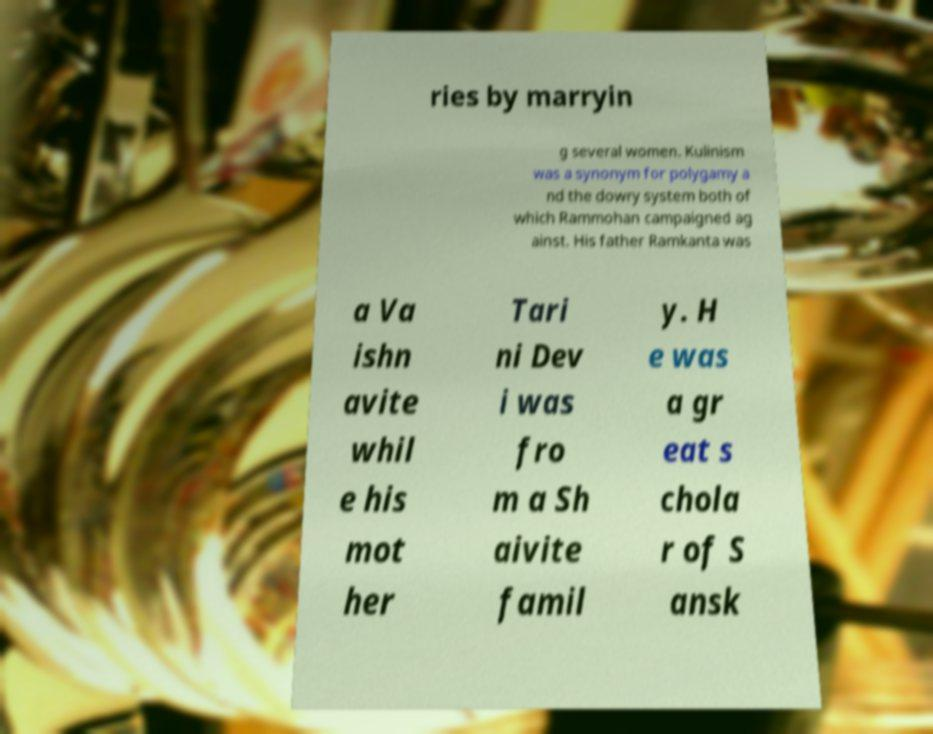For documentation purposes, I need the text within this image transcribed. Could you provide that? ries by marryin g several women. Kulinism was a synonym for polygamy a nd the dowry system both of which Rammohan campaigned ag ainst. His father Ramkanta was a Va ishn avite whil e his mot her Tari ni Dev i was fro m a Sh aivite famil y. H e was a gr eat s chola r of S ansk 